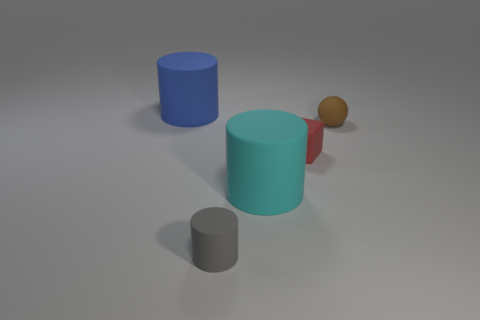Add 2 tiny gray matte things. How many objects exist? 7 Subtract all cubes. How many objects are left? 4 Subtract 0 blue spheres. How many objects are left? 5 Subtract all matte things. Subtract all big yellow matte things. How many objects are left? 0 Add 4 tiny matte objects. How many tiny matte objects are left? 7 Add 5 small red metal cylinders. How many small red metal cylinders exist? 5 